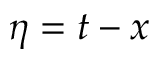<formula> <loc_0><loc_0><loc_500><loc_500>\eta = t - x</formula> 